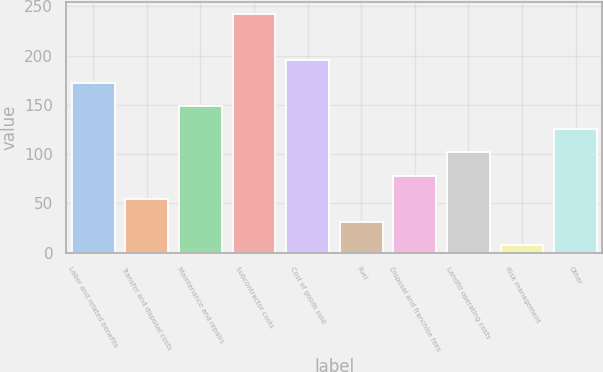<chart> <loc_0><loc_0><loc_500><loc_500><bar_chart><fcel>Labor and related benefits<fcel>Transfer and disposal costs<fcel>Maintenance and repairs<fcel>Subcontractor costs<fcel>Cost of goods sold<fcel>Fuel<fcel>Disposal and franchise fees<fcel>Landfill operating costs<fcel>Risk management<fcel>Other<nl><fcel>171.8<fcel>54.8<fcel>148.4<fcel>242<fcel>195.2<fcel>31.4<fcel>78.2<fcel>101.6<fcel>8<fcel>125<nl></chart> 